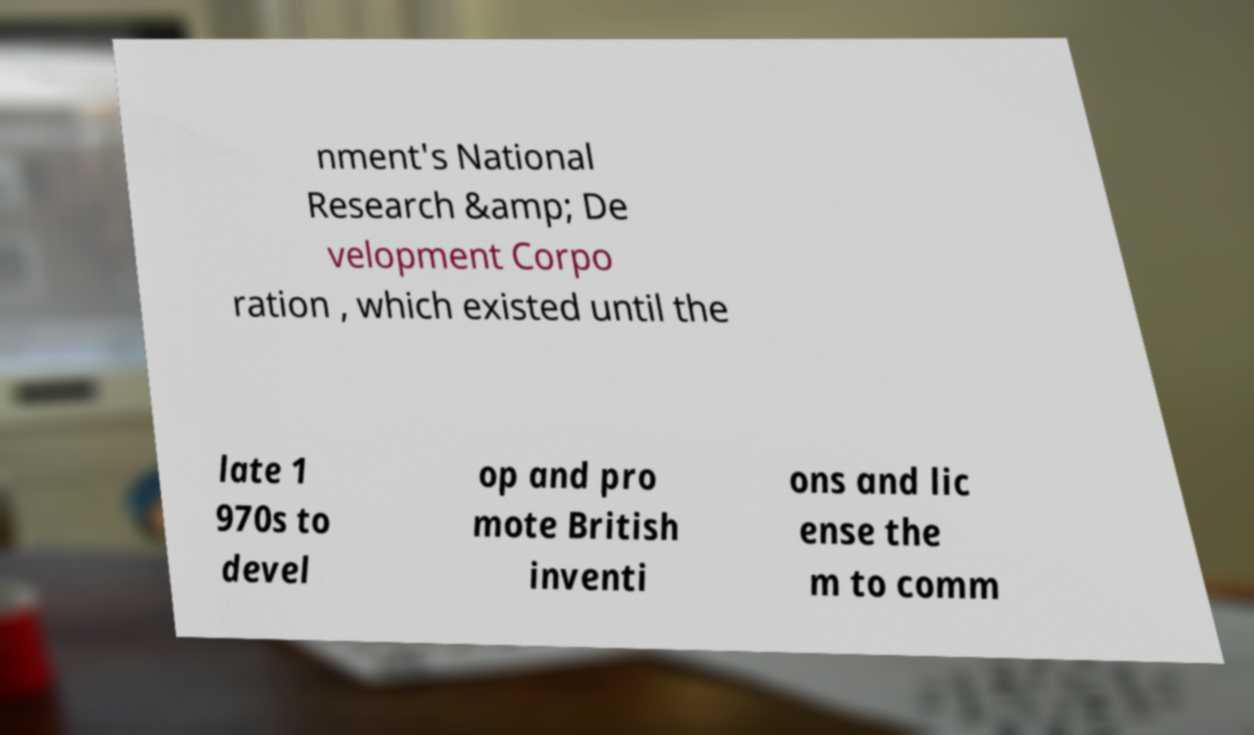Could you assist in decoding the text presented in this image and type it out clearly? nment's National Research &amp; De velopment Corpo ration , which existed until the late 1 970s to devel op and pro mote British inventi ons and lic ense the m to comm 